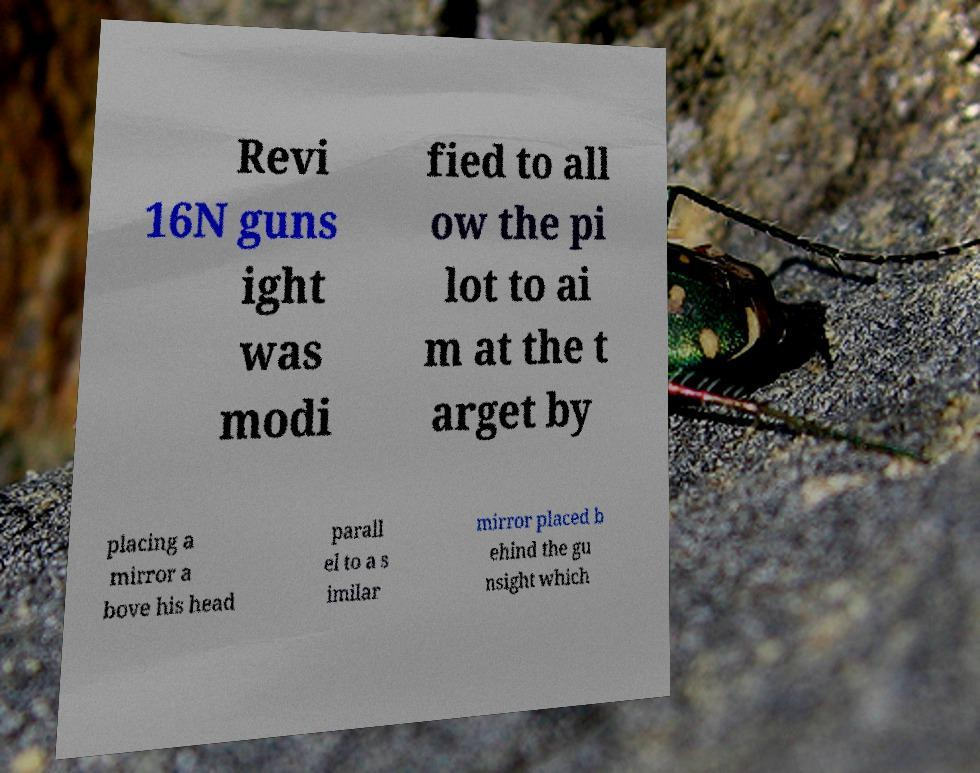What messages or text are displayed in this image? I need them in a readable, typed format. Revi 16N guns ight was modi fied to all ow the pi lot to ai m at the t arget by placing a mirror a bove his head parall el to a s imilar mirror placed b ehind the gu nsight which 